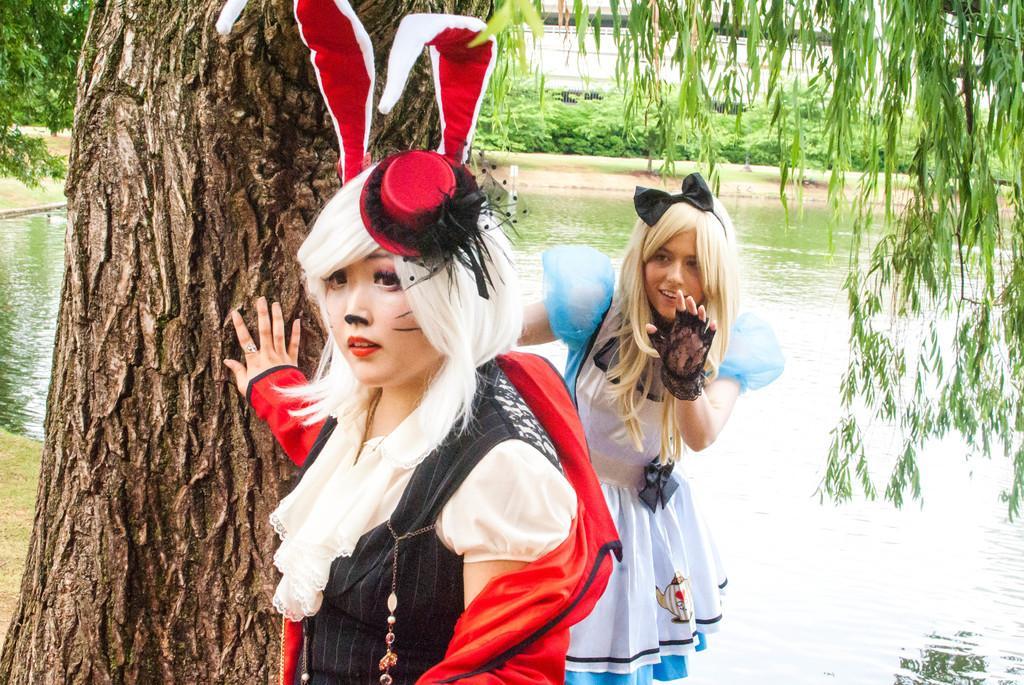How would you summarize this image in a sentence or two? In this image I see 2 women who are wearing costumes and I see the water and I see a tree over here and I see the plants in the background. 